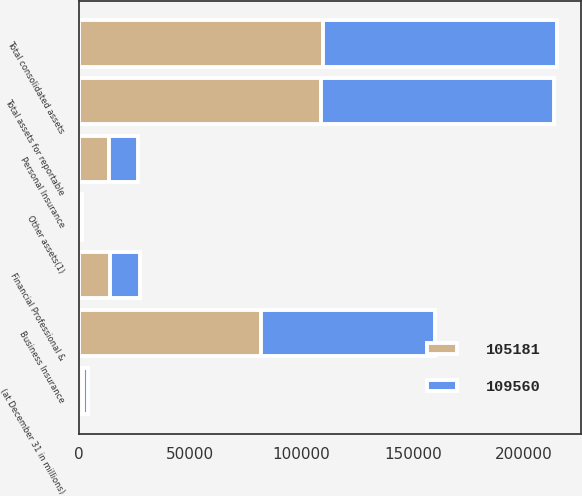Convert chart to OTSL. <chart><loc_0><loc_0><loc_500><loc_500><stacked_bar_chart><ecel><fcel>(at December 31 in millions)<fcel>Business Insurance<fcel>Financial Professional &<fcel>Personal Insurance<fcel>Total assets for reportable<fcel>Other assets(1)<fcel>Total consolidated assets<nl><fcel>109560<fcel>2010<fcel>78119<fcel>13461<fcel>12994<fcel>104574<fcel>607<fcel>105181<nl><fcel>105181<fcel>2009<fcel>81705<fcel>13920<fcel>13328<fcel>108953<fcel>607<fcel>109560<nl></chart> 